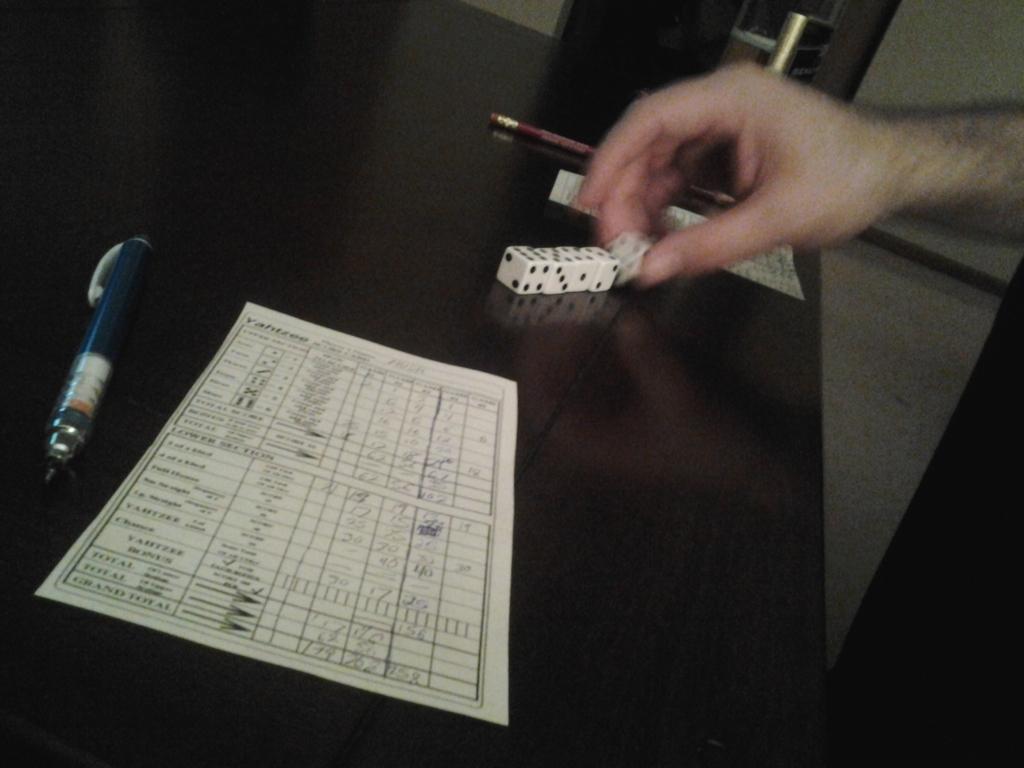Please provide a concise description of this image. In this image there is a table having a paper, pen, pencil, dices are on it. Right side there is a person hand holding a dice. Behind the table there is a door. 